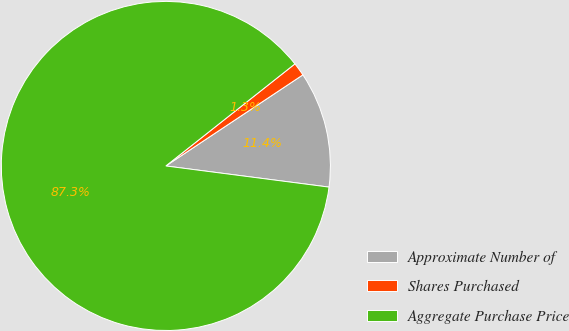<chart> <loc_0><loc_0><loc_500><loc_500><pie_chart><fcel>Approximate Number of<fcel>Shares Purchased<fcel>Aggregate Purchase Price<nl><fcel>11.39%<fcel>1.31%<fcel>87.3%<nl></chart> 